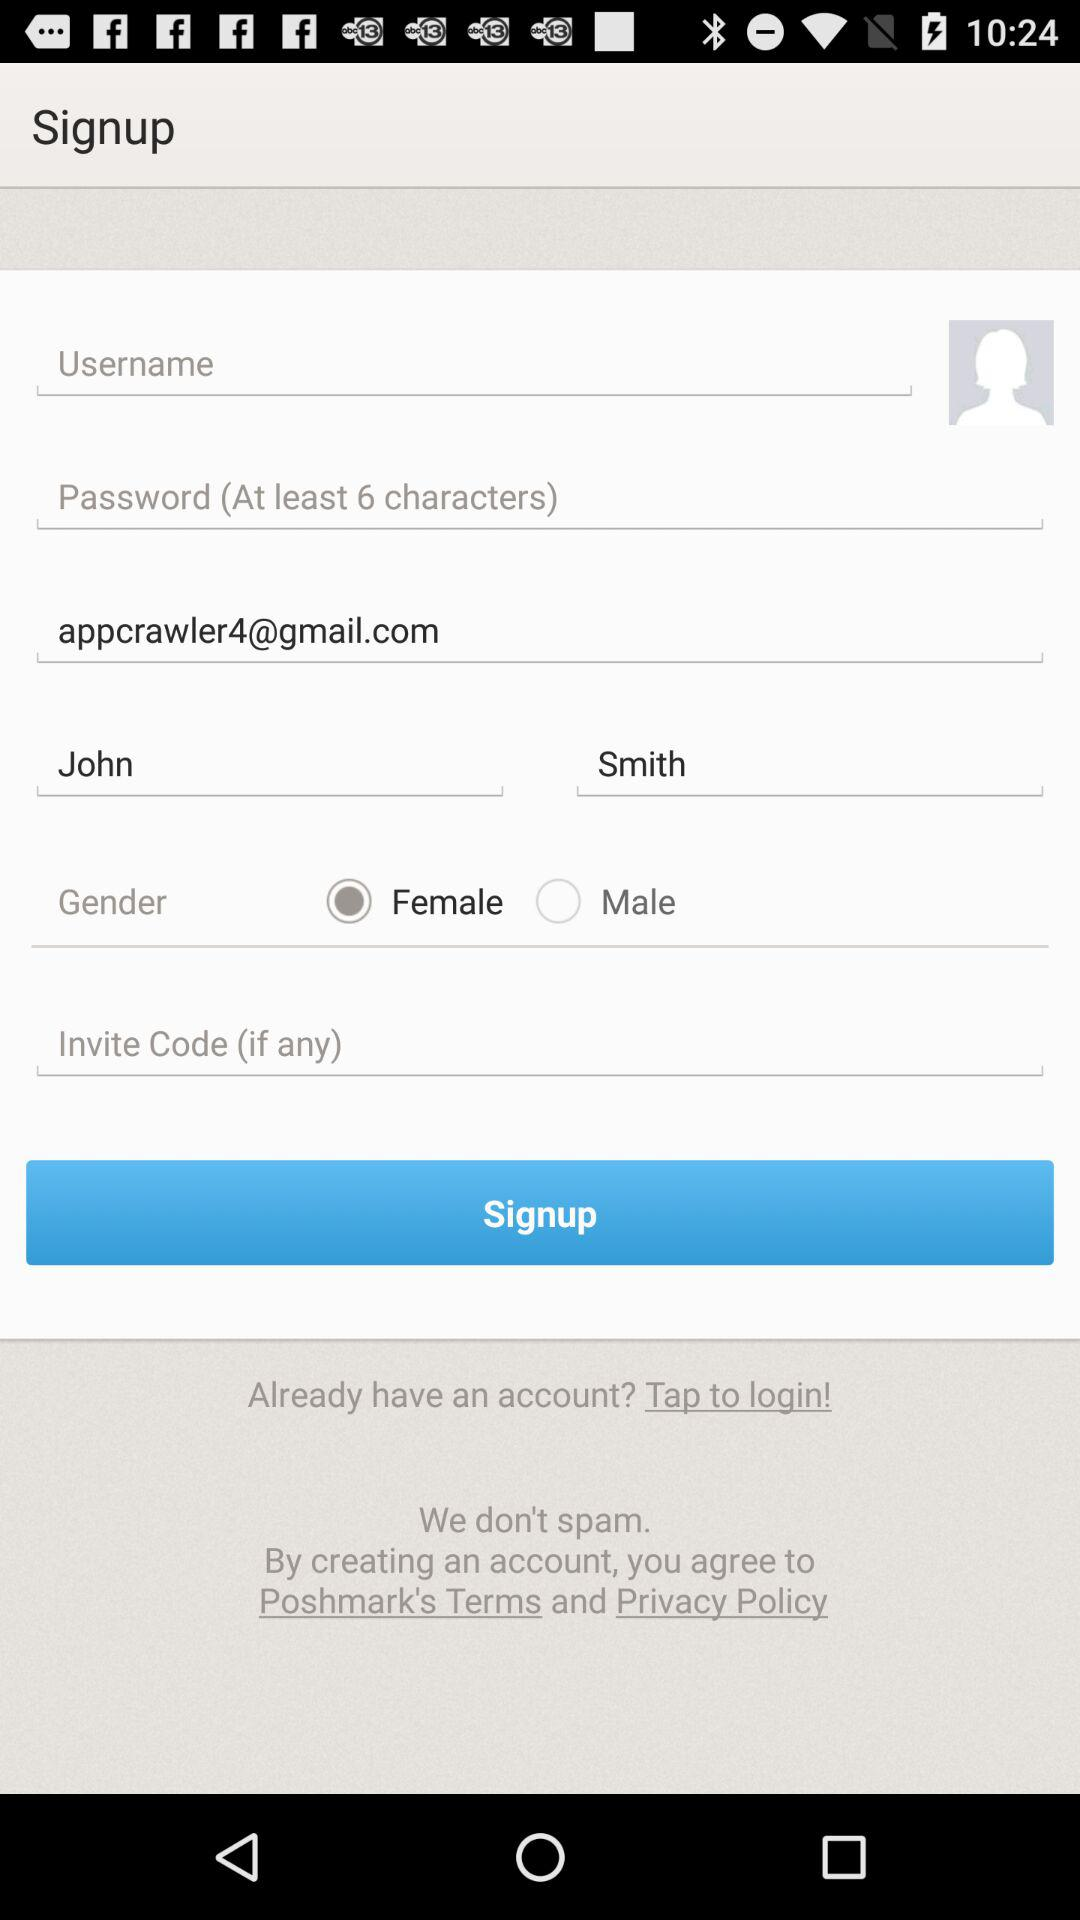What is the email ID of John? The email ID is appcrawler4@gmail.com. 